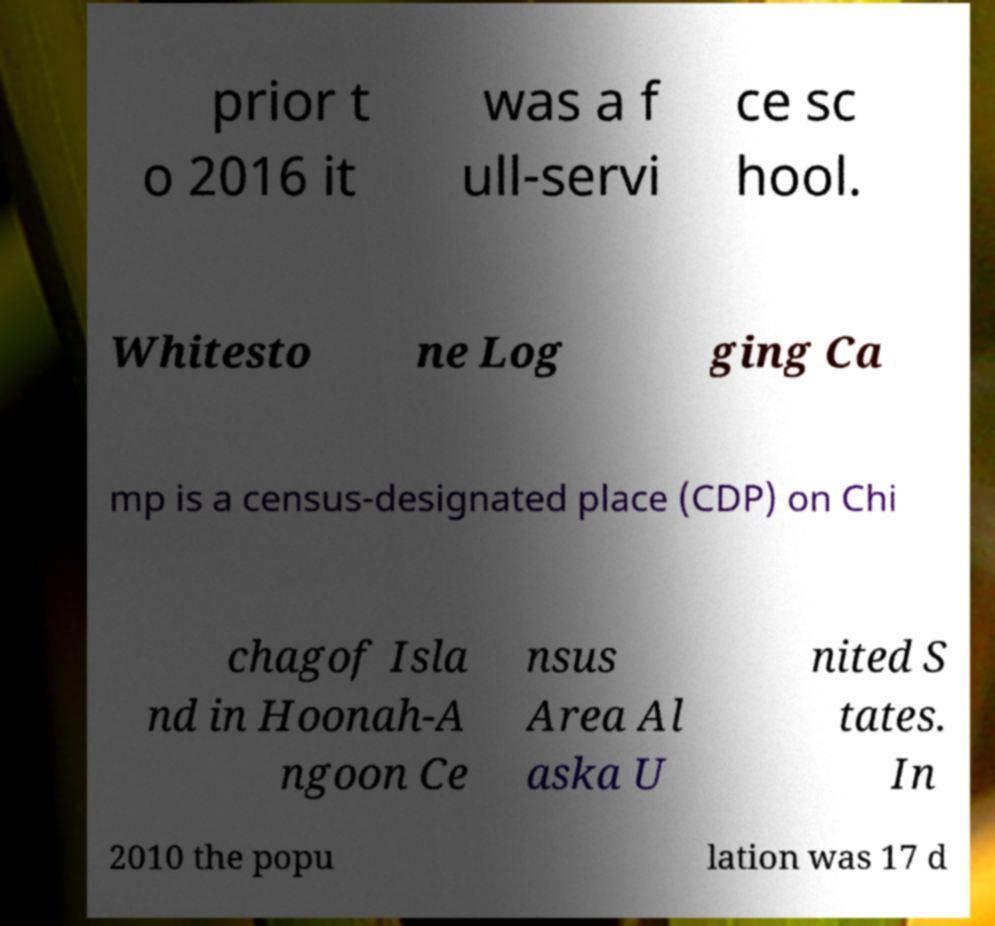Please identify and transcribe the text found in this image. prior t o 2016 it was a f ull-servi ce sc hool. Whitesto ne Log ging Ca mp is a census-designated place (CDP) on Chi chagof Isla nd in Hoonah-A ngoon Ce nsus Area Al aska U nited S tates. In 2010 the popu lation was 17 d 